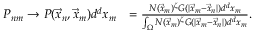<formula> <loc_0><loc_0><loc_500><loc_500>\begin{array} { r l } { P _ { n m } \rightarrow P ( \vec { x } _ { n } , \vec { x } _ { m } ) d ^ { d } x _ { m } } & { = \frac { N ( \vec { x } _ { m } ) ^ { \zeta } G ( | \vec { x } _ { m } - \vec { x } _ { n } | ) d ^ { d } x _ { m } } { \int _ { \Omega } N ( \vec { x } _ { m } ) ^ { \zeta } G ( | \vec { x } _ { m } - \vec { x } _ { n } | ) d ^ { d } x _ { m } } . } \end{array}</formula> 